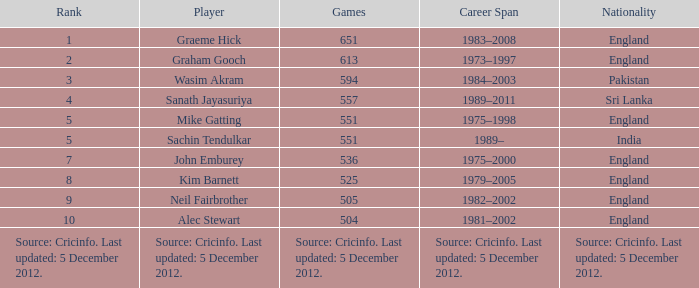What is Wasim Akram's rank? 3.0. 